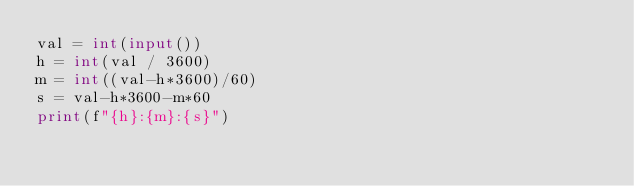<code> <loc_0><loc_0><loc_500><loc_500><_Python_>val = int(input())
h = int(val / 3600)
m = int((val-h*3600)/60)
s = val-h*3600-m*60
print(f"{h}:{m}:{s}")
</code> 